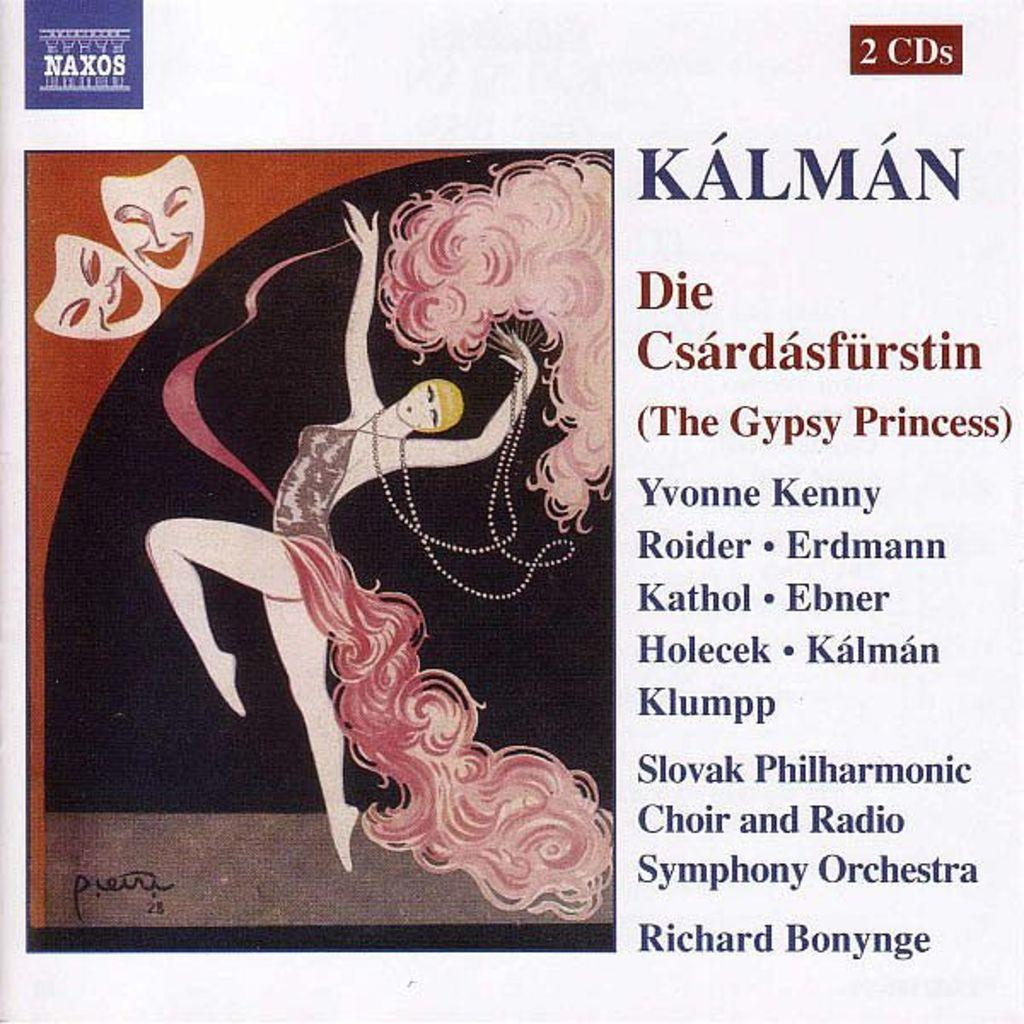What is featured on the poster in the image? The poster contains a painting of a girl. What else can be seen on the poster besides the painting? There is text on the poster. What type of celery is being used as a prop in the painting on the poster? There is no celery present in the painting on the poster; it features a girl. How long is the recess period for the students depicted in the painting on the poster? There are no students depicted in the painting on the poster, and therefore no recess period can be determined. 